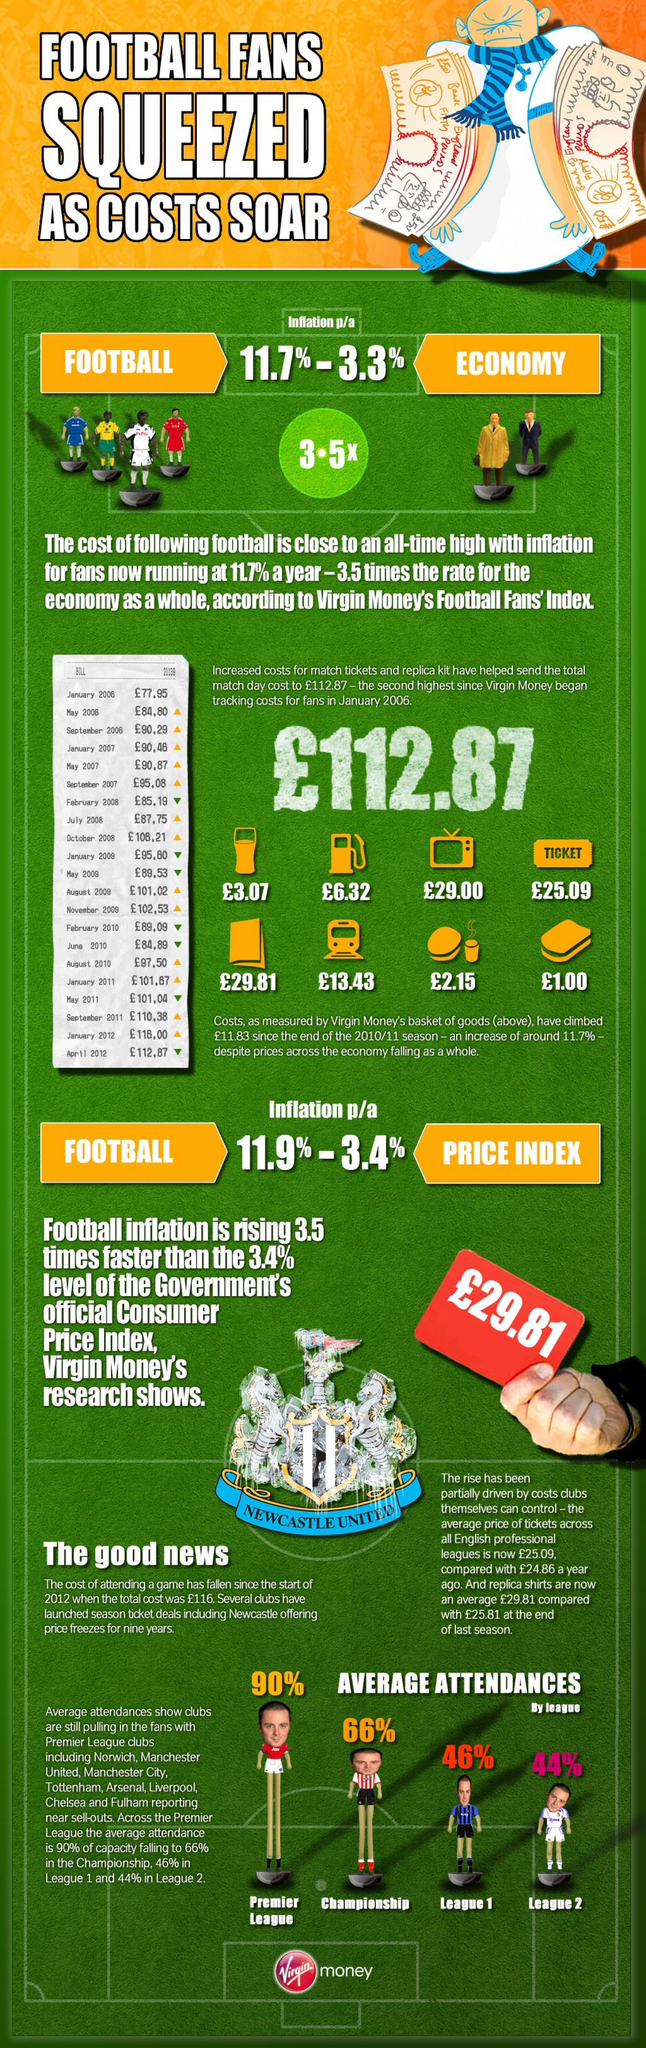Draw attention to some important aspects in this diagram. This infographic features the mentions of 8 Premier League clubs. 